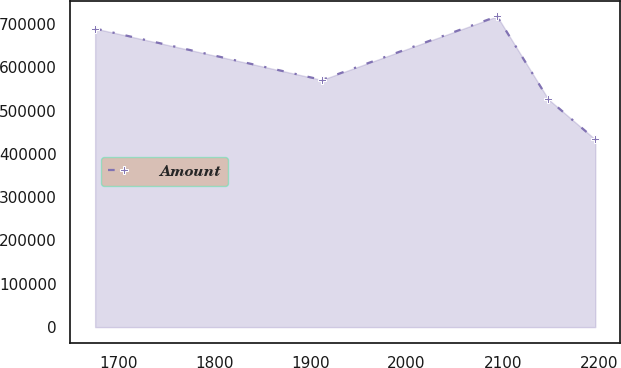Convert chart. <chart><loc_0><loc_0><loc_500><loc_500><line_chart><ecel><fcel>Amount<nl><fcel>1676.09<fcel>689230<nl><fcel>1911.86<fcel>570650<nl><fcel>2094.27<fcel>717369<nl><fcel>2147.55<fcel>525924<nl><fcel>2196.34<fcel>433154<nl></chart> 